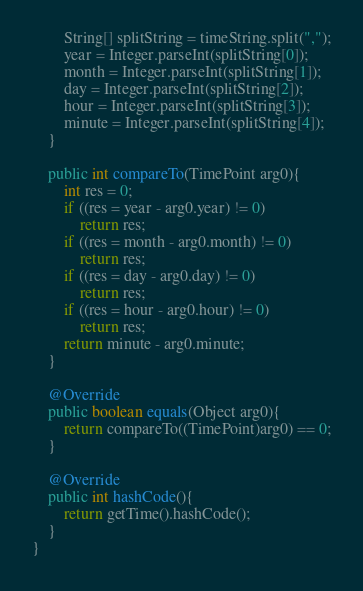<code> <loc_0><loc_0><loc_500><loc_500><_Java_>        String[] splitString = timeString.split(",");
        year = Integer.parseInt(splitString[0]);
        month = Integer.parseInt(splitString[1]);
        day = Integer.parseInt(splitString[2]);
        hour = Integer.parseInt(splitString[3]);
        minute = Integer.parseInt(splitString[4]);
    }

    public int compareTo(TimePoint arg0){
        int res = 0;
        if ((res = year - arg0.year) != 0)
            return res;
        if ((res = month - arg0.month) != 0)
            return res;
        if ((res = day - arg0.day) != 0)
            return res;
        if ((res = hour - arg0.hour) != 0)
            return res;
        return minute - arg0.minute;
    }

    @Override
    public boolean equals(Object arg0){
        return compareTo((TimePoint)arg0) == 0;
    }

    @Override
    public int hashCode(){
        return getTime().hashCode();
    }
}</code> 